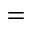Convert formula to latex. <formula><loc_0><loc_0><loc_500><loc_500>=</formula> 